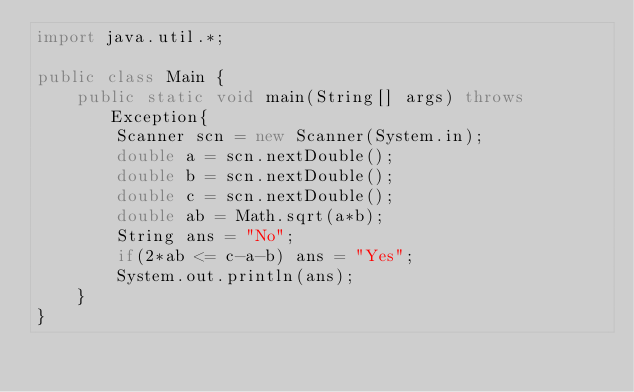<code> <loc_0><loc_0><loc_500><loc_500><_Java_>import java.util.*;

public class Main {
	public static void main(String[] args) throws Exception{
		Scanner scn = new Scanner(System.in);
		double a = scn.nextDouble();
		double b = scn.nextDouble();
      	double c = scn.nextDouble();
      	double ab = Math.sqrt(a*b);
      	String ans = "No";
      	if(2*ab <= c-a-b) ans = "Yes";
      	System.out.println(ans);
	}
}
</code> 